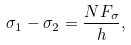Convert formula to latex. <formula><loc_0><loc_0><loc_500><loc_500>\sigma _ { 1 } - \sigma _ { 2 } = \frac { N F _ { \sigma } } { h } ,</formula> 